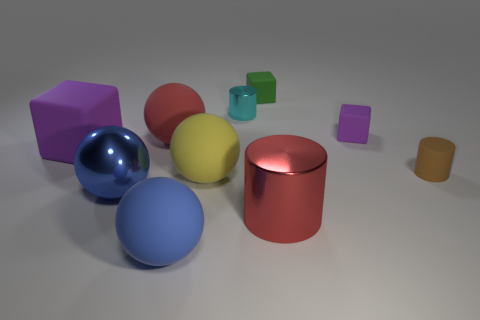Subtract all blue balls. How many were subtracted if there are1blue balls left? 1 Subtract all cylinders. How many objects are left? 7 Subtract all large metal cylinders. Subtract all large metal cylinders. How many objects are left? 8 Add 7 large red cylinders. How many large red cylinders are left? 8 Add 8 purple matte objects. How many purple matte objects exist? 10 Subtract 0 gray cylinders. How many objects are left? 10 